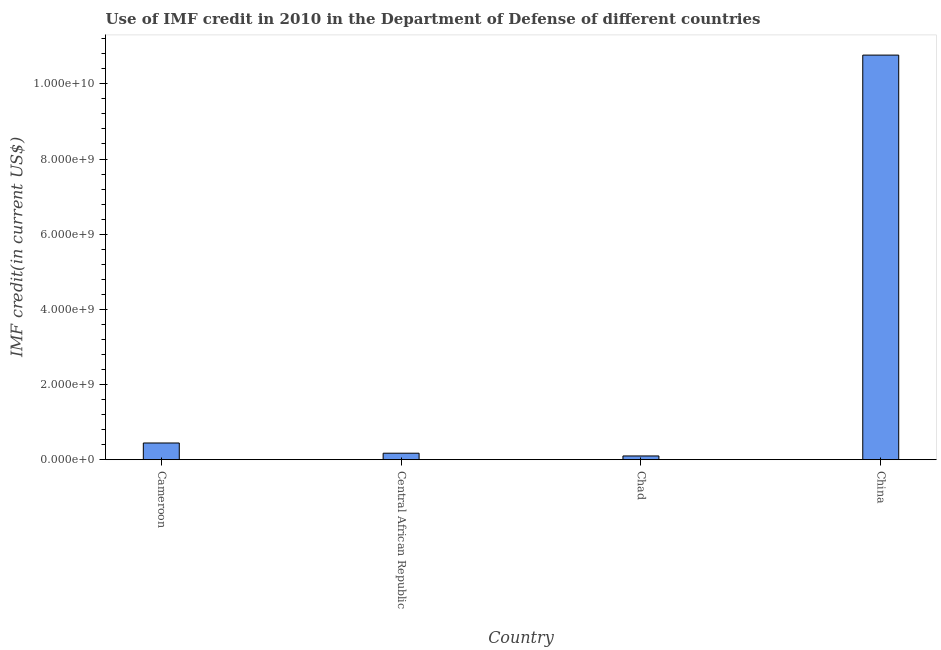Does the graph contain any zero values?
Give a very brief answer. No. Does the graph contain grids?
Offer a terse response. No. What is the title of the graph?
Ensure brevity in your answer.  Use of IMF credit in 2010 in the Department of Defense of different countries. What is the label or title of the Y-axis?
Make the answer very short. IMF credit(in current US$). What is the use of imf credit in dod in China?
Ensure brevity in your answer.  1.08e+1. Across all countries, what is the maximum use of imf credit in dod?
Offer a terse response. 1.08e+1. Across all countries, what is the minimum use of imf credit in dod?
Your answer should be compact. 9.94e+07. In which country was the use of imf credit in dod maximum?
Provide a short and direct response. China. In which country was the use of imf credit in dod minimum?
Ensure brevity in your answer.  Chad. What is the sum of the use of imf credit in dod?
Your answer should be compact. 1.15e+1. What is the difference between the use of imf credit in dod in Cameroon and China?
Ensure brevity in your answer.  -1.03e+1. What is the average use of imf credit in dod per country?
Make the answer very short. 2.87e+09. What is the median use of imf credit in dod?
Your answer should be very brief. 3.09e+08. What is the ratio of the use of imf credit in dod in Central African Republic to that in Chad?
Give a very brief answer. 1.74. Is the use of imf credit in dod in Chad less than that in China?
Your answer should be very brief. Yes. Is the difference between the use of imf credit in dod in Cameroon and Central African Republic greater than the difference between any two countries?
Your response must be concise. No. What is the difference between the highest and the second highest use of imf credit in dod?
Your answer should be compact. 1.03e+1. What is the difference between the highest and the lowest use of imf credit in dod?
Give a very brief answer. 1.07e+1. Are all the bars in the graph horizontal?
Your answer should be compact. No. What is the difference between two consecutive major ticks on the Y-axis?
Ensure brevity in your answer.  2.00e+09. What is the IMF credit(in current US$) in Cameroon?
Make the answer very short. 4.45e+08. What is the IMF credit(in current US$) in Central African Republic?
Provide a short and direct response. 1.73e+08. What is the IMF credit(in current US$) of Chad?
Ensure brevity in your answer.  9.94e+07. What is the IMF credit(in current US$) in China?
Provide a succinct answer. 1.08e+1. What is the difference between the IMF credit(in current US$) in Cameroon and Central African Republic?
Provide a succinct answer. 2.72e+08. What is the difference between the IMF credit(in current US$) in Cameroon and Chad?
Your answer should be very brief. 3.45e+08. What is the difference between the IMF credit(in current US$) in Cameroon and China?
Provide a short and direct response. -1.03e+1. What is the difference between the IMF credit(in current US$) in Central African Republic and Chad?
Your answer should be compact. 7.32e+07. What is the difference between the IMF credit(in current US$) in Central African Republic and China?
Give a very brief answer. -1.06e+1. What is the difference between the IMF credit(in current US$) in Chad and China?
Provide a short and direct response. -1.07e+1. What is the ratio of the IMF credit(in current US$) in Cameroon to that in Central African Republic?
Make the answer very short. 2.58. What is the ratio of the IMF credit(in current US$) in Cameroon to that in Chad?
Your answer should be compact. 4.47. What is the ratio of the IMF credit(in current US$) in Cameroon to that in China?
Your answer should be compact. 0.04. What is the ratio of the IMF credit(in current US$) in Central African Republic to that in Chad?
Ensure brevity in your answer.  1.74. What is the ratio of the IMF credit(in current US$) in Central African Republic to that in China?
Ensure brevity in your answer.  0.02. What is the ratio of the IMF credit(in current US$) in Chad to that in China?
Your response must be concise. 0.01. 